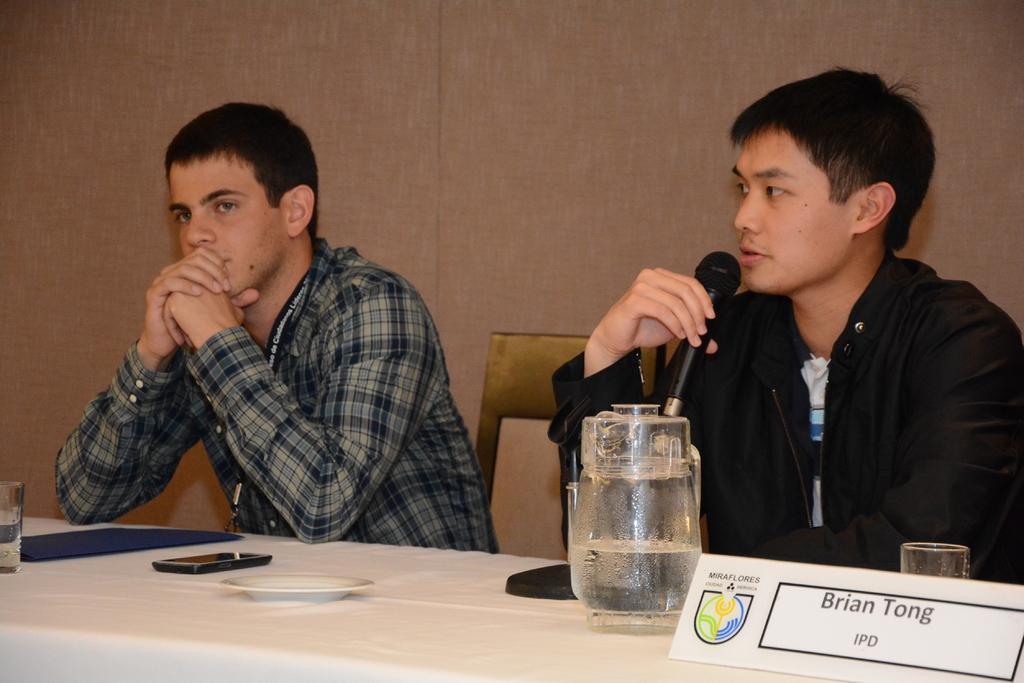Could you give a brief overview of what you see in this image? we can see in the picture that two boys are sitting beside on a chair and one boy is talking on a microphone and the other one is listening to him. He is wearing checked shirt and this boy is wearing a jacket which is in black color. This is a name plate and a glass. This one is a water jar. 